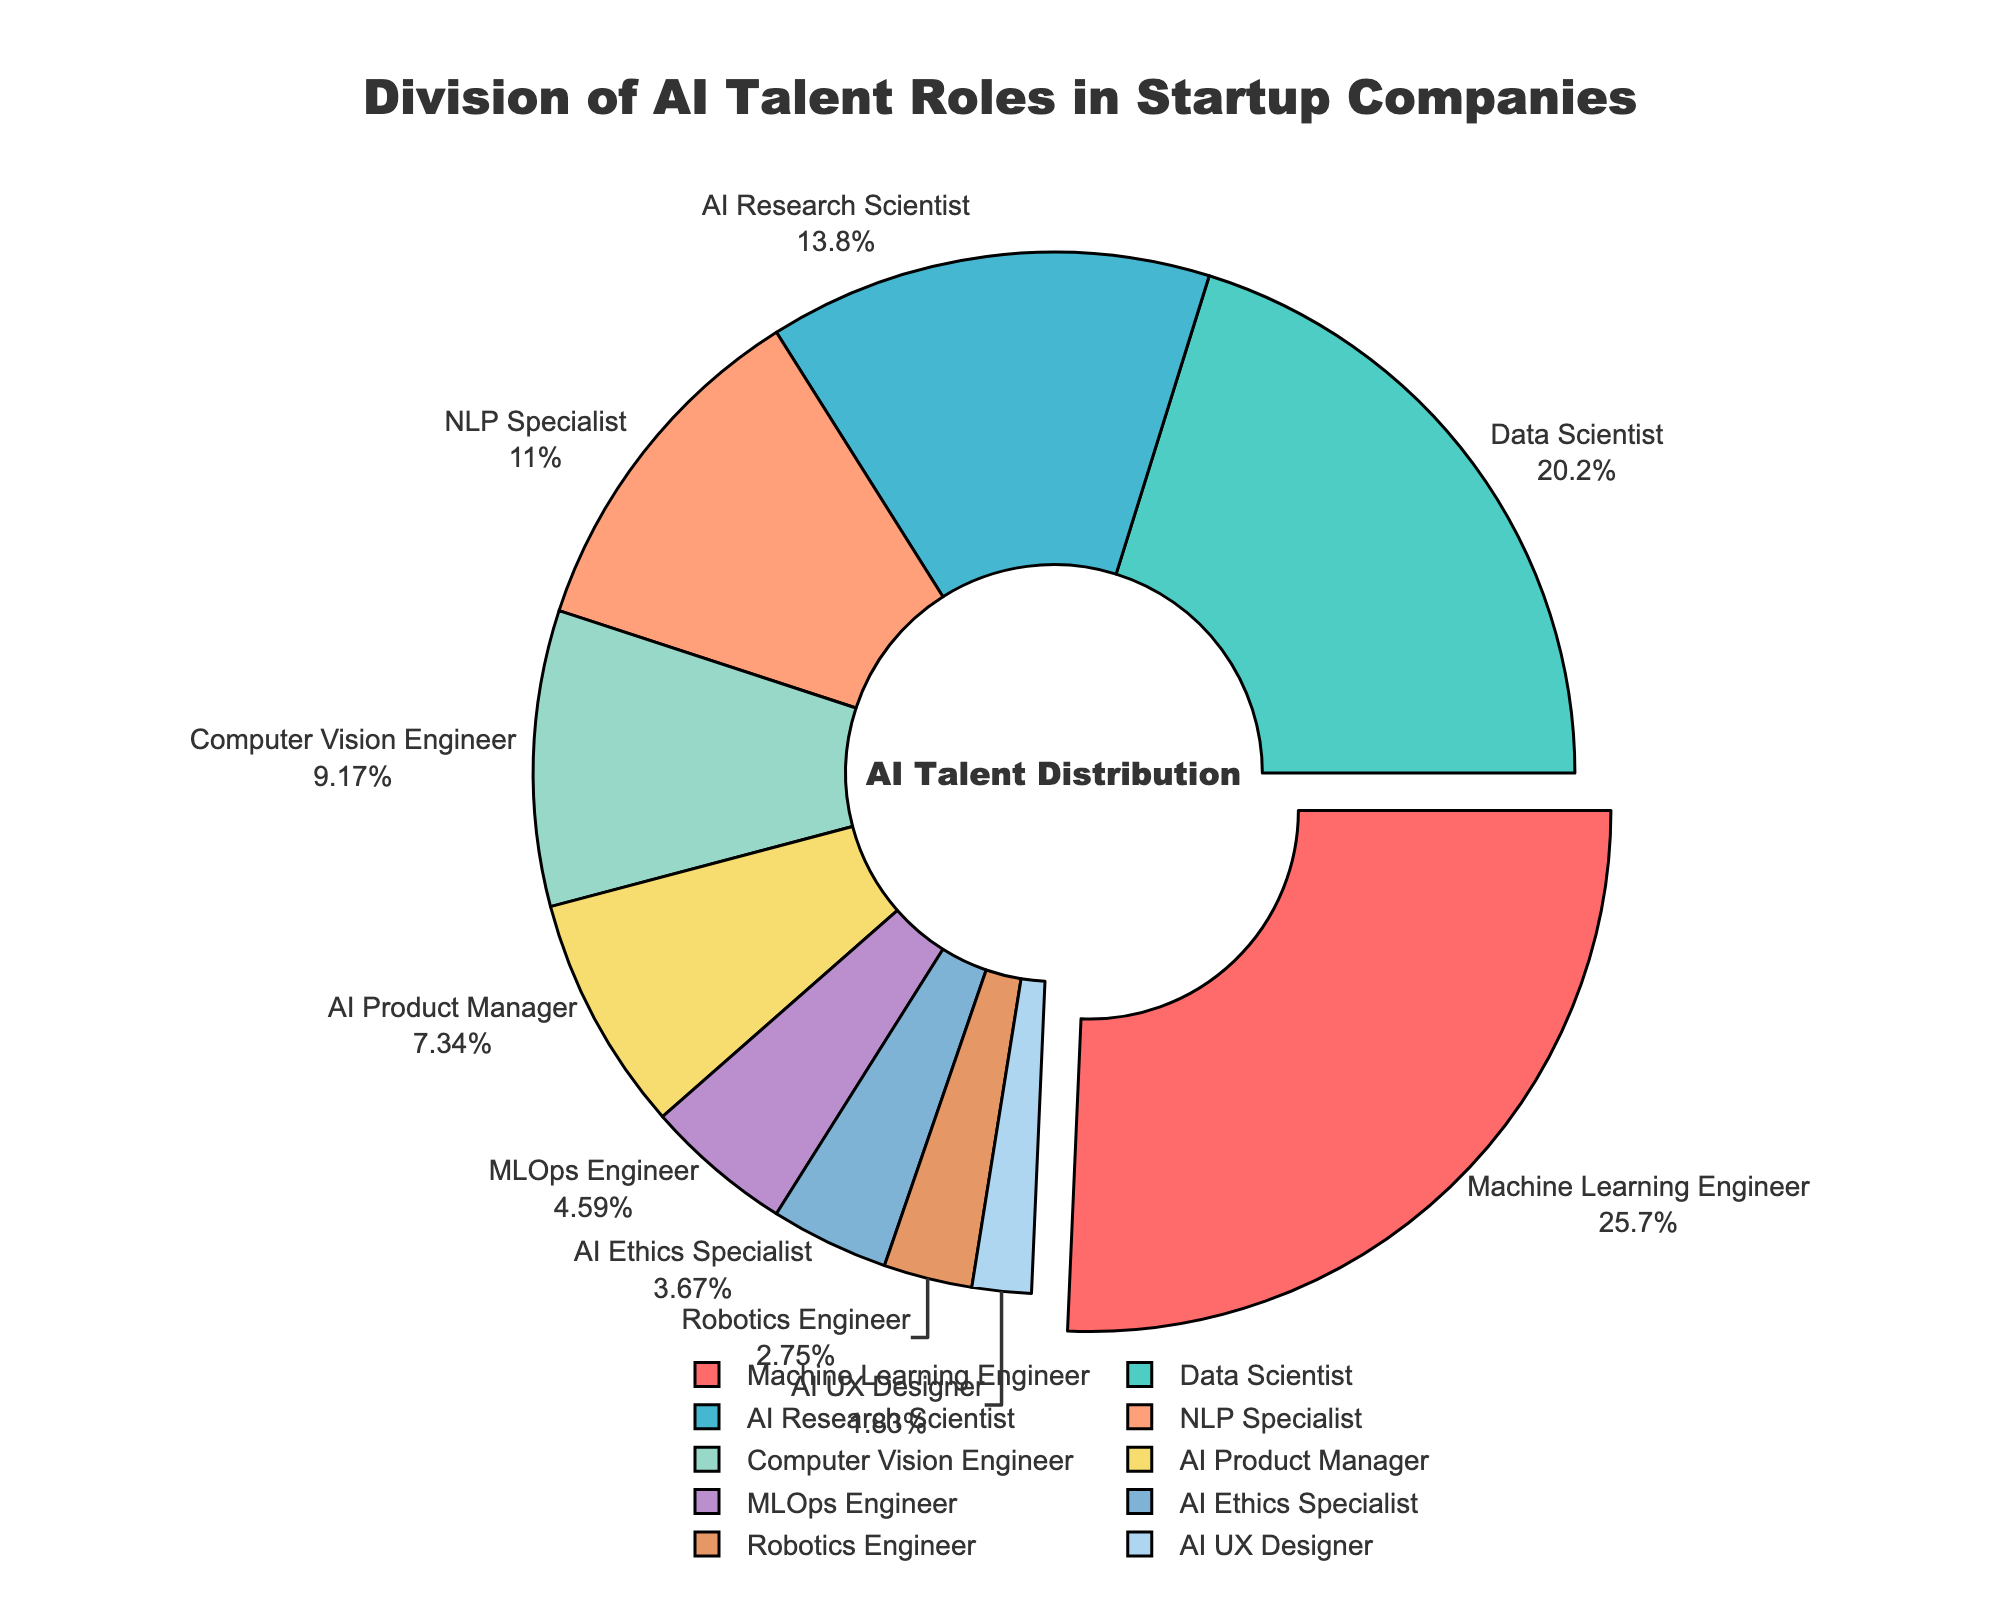What percentage of AI roles do Machine Learning Engineers and Data Scientists make up together? To find the combined percentage, we sum the individual percentages of Machine Learning Engineers (28%) and Data Scientists (22%). Adding these together gives 28% + 22% = 50%.
Answer: 50% Which role has the lowest percentage in the division of AI talent? From the pie chart, we can observe the percentages of each role. The role with the lowest percentage is AI UX Designer, which represents 2% of the division.
Answer: AI UX Designer Is the percentage of MLOps Engineers higher or lower than that of AI Product Managers? By comparing the percentages from the chart, we see that MLOps Engineers make up 5%, and AI Product Managers make up 8%. Since 5% is lower than 8%, the percentage of MLOps Engineers is lower.
Answer: Lower How many roles have a percentage less than 10%? To determine this, we count the roles with percentages under 10%. These roles are AI Product Manager (8%), MLOps Engineer (5%), AI Ethics Specialist (4%), Robotics Engineer (3%), and AI UX Designer (2%). There are 5 roles in total.
Answer: 5 What is the average percentage of the following roles: AI Research Scientist, NLP Specialist, and Computer Vision Engineer? To find the average, we sum the percentages of these roles: AI Research Scientist (15%), NLP Specialist (12%), and Computer Vision Engineer (10%). The sum is 15% + 12% + 10% = 37%. The number of roles is 3, so the average is 37% / 3 = 12.33%.
Answer: 12.33% Which role in AI is represented by the darker blue color? Observing the colors in the pie chart, we identify the darker blue color to be part of the segment representing the NLP Specialist, which comprises 12%.
Answer: NLP Specialist If the percentage of AI Ethics Specialists doubled, what would be their new percentage, and how would it compare to the current percentage of Computer Vision Engineers? Doubling the percentage of AI Ethics Specialists (4%) gives 4% * 2 = 8%. The current percentage of Computer Vision Engineers is 10%. Thus, 8% is still less than 10%.
Answer: 8%, less Which role has the maximum percentage and is visually pulled out slightly from the pie chart? The role with the maximum percentage and visually pulled out from the chart is Machine Learning Engineer, comprising 28%.
Answer: Machine Learning Engineer Among AI Research Scientist, NLP Specialist, and Computer Vision Engineer, which role has the smallest percentage? Comparing the percentages: AI Research Scientist (15%), NLP Specialist (12%), and Computer Vision Engineer (10%), we find the smallest percentage is for Computer Vision Engineer with 10%.
Answer: Computer Vision Engineer 